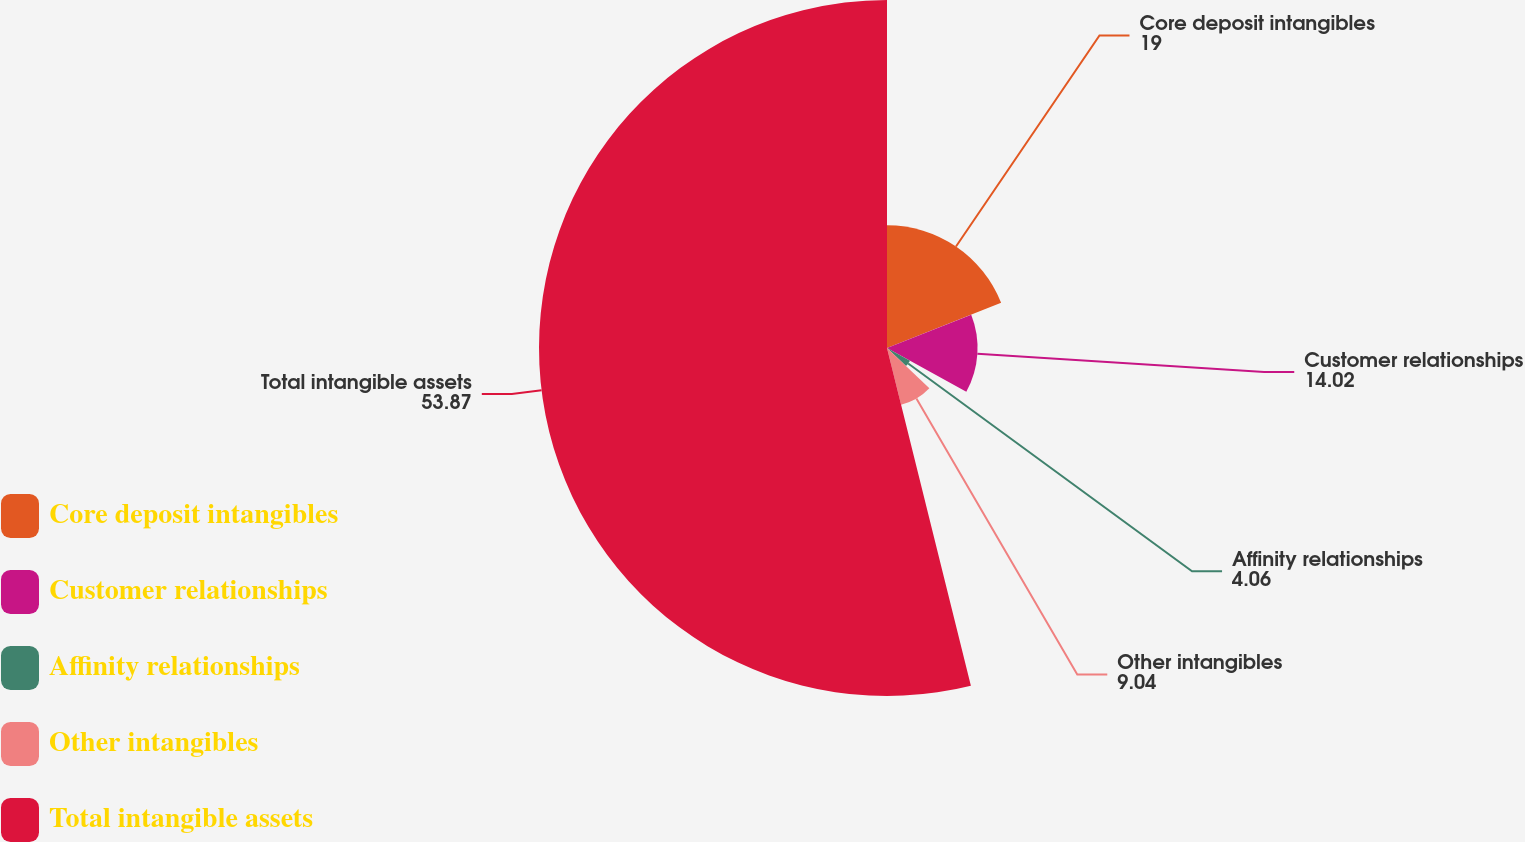Convert chart. <chart><loc_0><loc_0><loc_500><loc_500><pie_chart><fcel>Core deposit intangibles<fcel>Customer relationships<fcel>Affinity relationships<fcel>Other intangibles<fcel>Total intangible assets<nl><fcel>19.0%<fcel>14.02%<fcel>4.06%<fcel>9.04%<fcel>53.87%<nl></chart> 